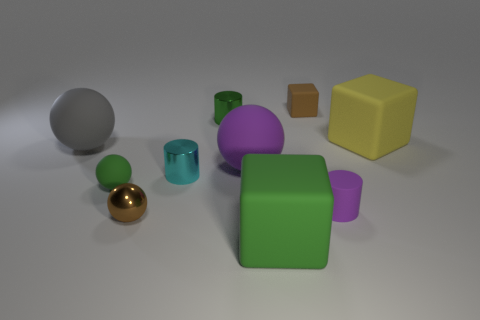There is a big object that is the same color as the rubber cylinder; what is its shape?
Offer a very short reply. Sphere. Is the brown rubber object the same shape as the yellow matte object?
Provide a succinct answer. Yes. What is the green thing that is both in front of the cyan cylinder and to the left of the big green cube made of?
Your response must be concise. Rubber. The green matte sphere has what size?
Keep it short and to the point. Small. There is another large thing that is the same shape as the big yellow rubber object; what color is it?
Provide a succinct answer. Green. There is a block that is on the left side of the brown cube; is it the same size as the purple object to the left of the big green block?
Your response must be concise. Yes. Are there the same number of small green things in front of the large gray matte sphere and tiny brown spheres that are behind the brown ball?
Ensure brevity in your answer.  No. There is a brown matte object; is its size the same as the rubber block that is in front of the big yellow thing?
Offer a very short reply. No. Are there any balls that are left of the brown thing that is behind the big yellow matte thing?
Provide a short and direct response. Yes. Is there a big gray rubber object of the same shape as the large purple rubber object?
Offer a very short reply. Yes. 